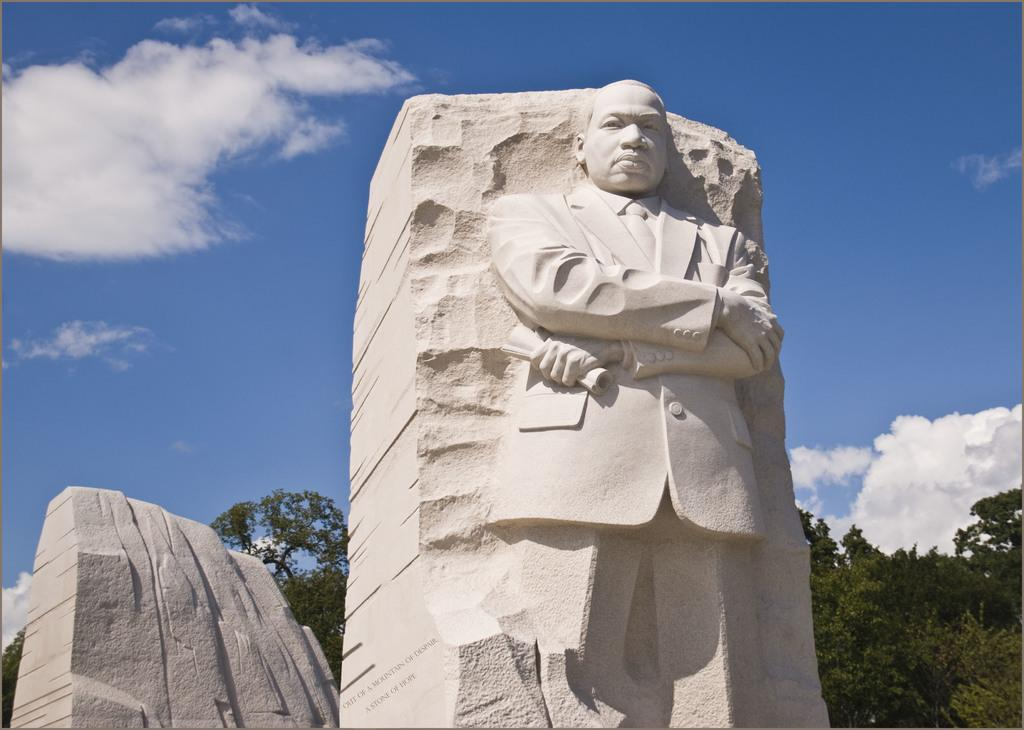What can be seen in the background of the image? The sky is visible in the image. What is present in the sky? There are clouds in the sky. What type of natural elements can be seen in the image? There are trees in the image. What type of artwork is present in the image? There is a sculpture of a person in the image. Is there any blood visible on the sculpture in the image? There is no blood visible on the sculpture in the image. What type of servant is attending to the sculpture in the image? There is no servant present in the image; it only features the sculpture and the surrounding environment. 